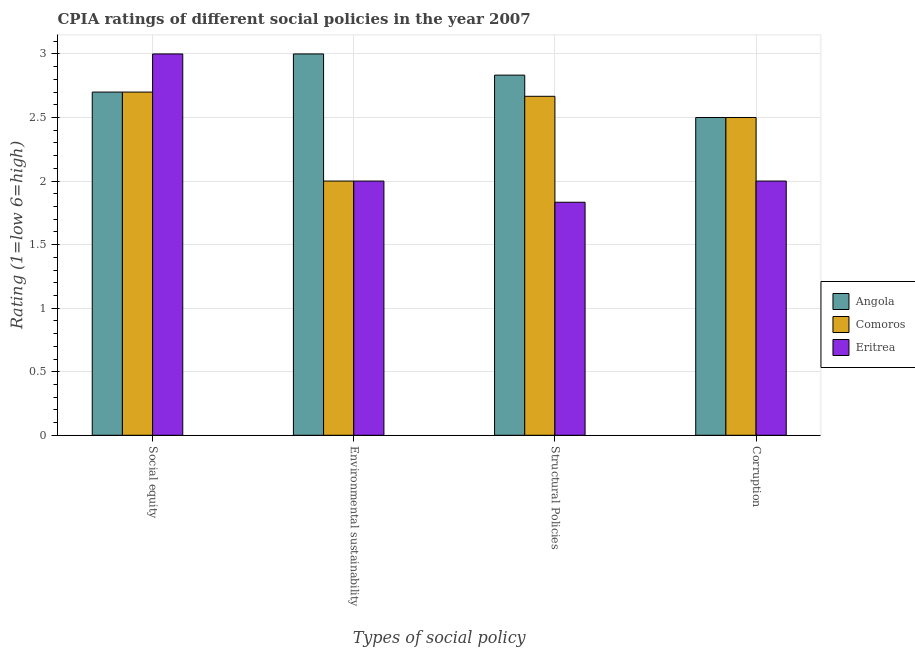How many groups of bars are there?
Give a very brief answer. 4. Are the number of bars per tick equal to the number of legend labels?
Provide a short and direct response. Yes. How many bars are there on the 3rd tick from the left?
Make the answer very short. 3. What is the label of the 3rd group of bars from the left?
Offer a terse response. Structural Policies. In which country was the cpia rating of environmental sustainability maximum?
Provide a short and direct response. Angola. In which country was the cpia rating of social equity minimum?
Offer a terse response. Angola. What is the total cpia rating of social equity in the graph?
Offer a terse response. 8.4. What is the difference between the cpia rating of social equity in Comoros and that in Angola?
Make the answer very short. 0. What is the difference between the cpia rating of social equity in Angola and the cpia rating of environmental sustainability in Comoros?
Make the answer very short. 0.7. What is the average cpia rating of structural policies per country?
Offer a very short reply. 2.44. What is the difference between the cpia rating of environmental sustainability and cpia rating of structural policies in Angola?
Your answer should be compact. 0.17. What is the ratio of the cpia rating of social equity in Eritrea to that in Angola?
Offer a very short reply. 1.11. Is the cpia rating of structural policies in Eritrea less than that in Comoros?
Your answer should be compact. Yes. Is the difference between the cpia rating of social equity in Angola and Eritrea greater than the difference between the cpia rating of corruption in Angola and Eritrea?
Offer a very short reply. No. What is the difference between the highest and the second highest cpia rating of structural policies?
Your answer should be compact. 0.17. What is the difference between the highest and the lowest cpia rating of environmental sustainability?
Your response must be concise. 1. In how many countries, is the cpia rating of environmental sustainability greater than the average cpia rating of environmental sustainability taken over all countries?
Provide a succinct answer. 1. Is the sum of the cpia rating of corruption in Angola and Comoros greater than the maximum cpia rating of social equity across all countries?
Keep it short and to the point. Yes. What does the 1st bar from the left in Corruption represents?
Your response must be concise. Angola. What does the 2nd bar from the right in Environmental sustainability represents?
Offer a terse response. Comoros. Is it the case that in every country, the sum of the cpia rating of social equity and cpia rating of environmental sustainability is greater than the cpia rating of structural policies?
Keep it short and to the point. Yes. How many bars are there?
Keep it short and to the point. 12. How many countries are there in the graph?
Your answer should be very brief. 3. Are the values on the major ticks of Y-axis written in scientific E-notation?
Provide a short and direct response. No. Where does the legend appear in the graph?
Offer a very short reply. Center right. How many legend labels are there?
Ensure brevity in your answer.  3. What is the title of the graph?
Keep it short and to the point. CPIA ratings of different social policies in the year 2007. Does "Tanzania" appear as one of the legend labels in the graph?
Your response must be concise. No. What is the label or title of the X-axis?
Keep it short and to the point. Types of social policy. What is the Rating (1=low 6=high) of Comoros in Social equity?
Your answer should be very brief. 2.7. What is the Rating (1=low 6=high) of Eritrea in Social equity?
Keep it short and to the point. 3. What is the Rating (1=low 6=high) of Angola in Environmental sustainability?
Provide a short and direct response. 3. What is the Rating (1=low 6=high) of Comoros in Environmental sustainability?
Offer a very short reply. 2. What is the Rating (1=low 6=high) of Angola in Structural Policies?
Ensure brevity in your answer.  2.83. What is the Rating (1=low 6=high) in Comoros in Structural Policies?
Your answer should be very brief. 2.67. What is the Rating (1=low 6=high) of Eritrea in Structural Policies?
Keep it short and to the point. 1.83. What is the Rating (1=low 6=high) in Comoros in Corruption?
Your answer should be compact. 2.5. Across all Types of social policy, what is the maximum Rating (1=low 6=high) of Comoros?
Ensure brevity in your answer.  2.7. Across all Types of social policy, what is the maximum Rating (1=low 6=high) of Eritrea?
Your answer should be compact. 3. Across all Types of social policy, what is the minimum Rating (1=low 6=high) in Comoros?
Your answer should be very brief. 2. Across all Types of social policy, what is the minimum Rating (1=low 6=high) in Eritrea?
Offer a very short reply. 1.83. What is the total Rating (1=low 6=high) of Angola in the graph?
Offer a terse response. 11.03. What is the total Rating (1=low 6=high) in Comoros in the graph?
Offer a terse response. 9.87. What is the total Rating (1=low 6=high) in Eritrea in the graph?
Your answer should be compact. 8.83. What is the difference between the Rating (1=low 6=high) in Angola in Social equity and that in Environmental sustainability?
Your response must be concise. -0.3. What is the difference between the Rating (1=low 6=high) in Angola in Social equity and that in Structural Policies?
Your answer should be very brief. -0.13. What is the difference between the Rating (1=low 6=high) in Comoros in Social equity and that in Structural Policies?
Provide a short and direct response. 0.03. What is the difference between the Rating (1=low 6=high) in Eritrea in Social equity and that in Structural Policies?
Make the answer very short. 1.17. What is the difference between the Rating (1=low 6=high) of Angola in Social equity and that in Corruption?
Provide a short and direct response. 0.2. What is the difference between the Rating (1=low 6=high) in Comoros in Social equity and that in Corruption?
Your response must be concise. 0.2. What is the difference between the Rating (1=low 6=high) in Comoros in Environmental sustainability and that in Structural Policies?
Ensure brevity in your answer.  -0.67. What is the difference between the Rating (1=low 6=high) in Eritrea in Environmental sustainability and that in Structural Policies?
Your answer should be compact. 0.17. What is the difference between the Rating (1=low 6=high) of Comoros in Environmental sustainability and that in Corruption?
Provide a short and direct response. -0.5. What is the difference between the Rating (1=low 6=high) of Comoros in Structural Policies and that in Corruption?
Offer a terse response. 0.17. What is the difference between the Rating (1=low 6=high) in Eritrea in Structural Policies and that in Corruption?
Provide a short and direct response. -0.17. What is the difference between the Rating (1=low 6=high) of Angola in Social equity and the Rating (1=low 6=high) of Comoros in Environmental sustainability?
Your answer should be very brief. 0.7. What is the difference between the Rating (1=low 6=high) of Angola in Social equity and the Rating (1=low 6=high) of Eritrea in Environmental sustainability?
Offer a very short reply. 0.7. What is the difference between the Rating (1=low 6=high) of Comoros in Social equity and the Rating (1=low 6=high) of Eritrea in Environmental sustainability?
Provide a succinct answer. 0.7. What is the difference between the Rating (1=low 6=high) in Angola in Social equity and the Rating (1=low 6=high) in Eritrea in Structural Policies?
Provide a short and direct response. 0.87. What is the difference between the Rating (1=low 6=high) of Comoros in Social equity and the Rating (1=low 6=high) of Eritrea in Structural Policies?
Make the answer very short. 0.87. What is the difference between the Rating (1=low 6=high) in Angola in Social equity and the Rating (1=low 6=high) in Comoros in Corruption?
Provide a short and direct response. 0.2. What is the difference between the Rating (1=low 6=high) of Angola in Social equity and the Rating (1=low 6=high) of Eritrea in Corruption?
Provide a succinct answer. 0.7. What is the difference between the Rating (1=low 6=high) of Angola in Structural Policies and the Rating (1=low 6=high) of Comoros in Corruption?
Your response must be concise. 0.33. What is the average Rating (1=low 6=high) of Angola per Types of social policy?
Offer a very short reply. 2.76. What is the average Rating (1=low 6=high) of Comoros per Types of social policy?
Provide a short and direct response. 2.47. What is the average Rating (1=low 6=high) in Eritrea per Types of social policy?
Keep it short and to the point. 2.21. What is the difference between the Rating (1=low 6=high) in Angola and Rating (1=low 6=high) in Comoros in Social equity?
Your response must be concise. 0. What is the difference between the Rating (1=low 6=high) of Angola and Rating (1=low 6=high) of Eritrea in Social equity?
Your answer should be compact. -0.3. What is the difference between the Rating (1=low 6=high) of Angola and Rating (1=low 6=high) of Comoros in Structural Policies?
Your answer should be compact. 0.17. What is the difference between the Rating (1=low 6=high) of Angola and Rating (1=low 6=high) of Eritrea in Structural Policies?
Ensure brevity in your answer.  1. What is the difference between the Rating (1=low 6=high) of Comoros and Rating (1=low 6=high) of Eritrea in Structural Policies?
Your response must be concise. 0.83. What is the difference between the Rating (1=low 6=high) of Angola and Rating (1=low 6=high) of Eritrea in Corruption?
Give a very brief answer. 0.5. What is the ratio of the Rating (1=low 6=high) of Comoros in Social equity to that in Environmental sustainability?
Provide a succinct answer. 1.35. What is the ratio of the Rating (1=low 6=high) of Angola in Social equity to that in Structural Policies?
Offer a very short reply. 0.95. What is the ratio of the Rating (1=low 6=high) in Comoros in Social equity to that in Structural Policies?
Make the answer very short. 1.01. What is the ratio of the Rating (1=low 6=high) in Eritrea in Social equity to that in Structural Policies?
Keep it short and to the point. 1.64. What is the ratio of the Rating (1=low 6=high) in Angola in Social equity to that in Corruption?
Keep it short and to the point. 1.08. What is the ratio of the Rating (1=low 6=high) of Angola in Environmental sustainability to that in Structural Policies?
Offer a terse response. 1.06. What is the ratio of the Rating (1=low 6=high) in Comoros in Environmental sustainability to that in Structural Policies?
Ensure brevity in your answer.  0.75. What is the ratio of the Rating (1=low 6=high) in Eritrea in Environmental sustainability to that in Structural Policies?
Your response must be concise. 1.09. What is the ratio of the Rating (1=low 6=high) of Angola in Environmental sustainability to that in Corruption?
Give a very brief answer. 1.2. What is the ratio of the Rating (1=low 6=high) in Comoros in Environmental sustainability to that in Corruption?
Your answer should be compact. 0.8. What is the ratio of the Rating (1=low 6=high) of Angola in Structural Policies to that in Corruption?
Your answer should be compact. 1.13. What is the ratio of the Rating (1=low 6=high) in Comoros in Structural Policies to that in Corruption?
Give a very brief answer. 1.07. What is the difference between the highest and the second highest Rating (1=low 6=high) in Angola?
Your response must be concise. 0.17. What is the difference between the highest and the second highest Rating (1=low 6=high) of Comoros?
Your answer should be compact. 0.03. What is the difference between the highest and the second highest Rating (1=low 6=high) of Eritrea?
Your response must be concise. 1. What is the difference between the highest and the lowest Rating (1=low 6=high) of Comoros?
Your answer should be very brief. 0.7. 